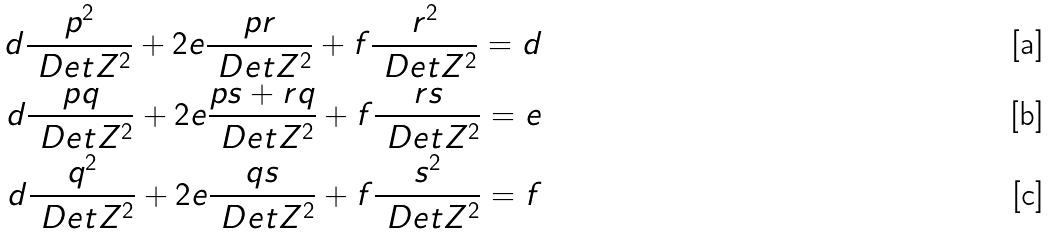<formula> <loc_0><loc_0><loc_500><loc_500>d \frac { p ^ { 2 } } { \ D e t { Z } ^ { 2 } } + 2 e \frac { p r } { \ D e t { Z } ^ { 2 } } + f \frac { r ^ { 2 } } { \ D e t { Z } ^ { 2 } } = d \\ d \frac { p q } { \ D e t { Z } ^ { 2 } } + 2 e \frac { p s + r q } { \ D e t { Z } ^ { 2 } } + f \frac { r s } { \ D e t { Z } ^ { 2 } } = e \\ d \frac { q ^ { 2 } } { \ D e t { Z } ^ { 2 } } + 2 e \frac { q s } { \ D e t { Z } ^ { 2 } } + f \frac { s ^ { 2 } } { \ D e t { Z } ^ { 2 } } = f</formula> 